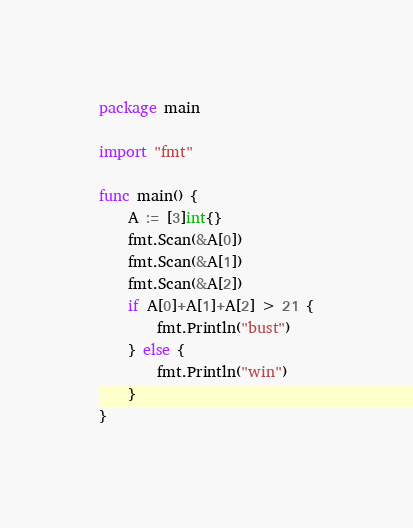Convert code to text. <code><loc_0><loc_0><loc_500><loc_500><_Go_>package main

import "fmt"

func main() {
	A := [3]int{}
	fmt.Scan(&A[0])
	fmt.Scan(&A[1])
	fmt.Scan(&A[2])
	if A[0]+A[1]+A[2] > 21 {
		fmt.Println("bust")
	} else {
		fmt.Println("win")
	}
}
</code> 